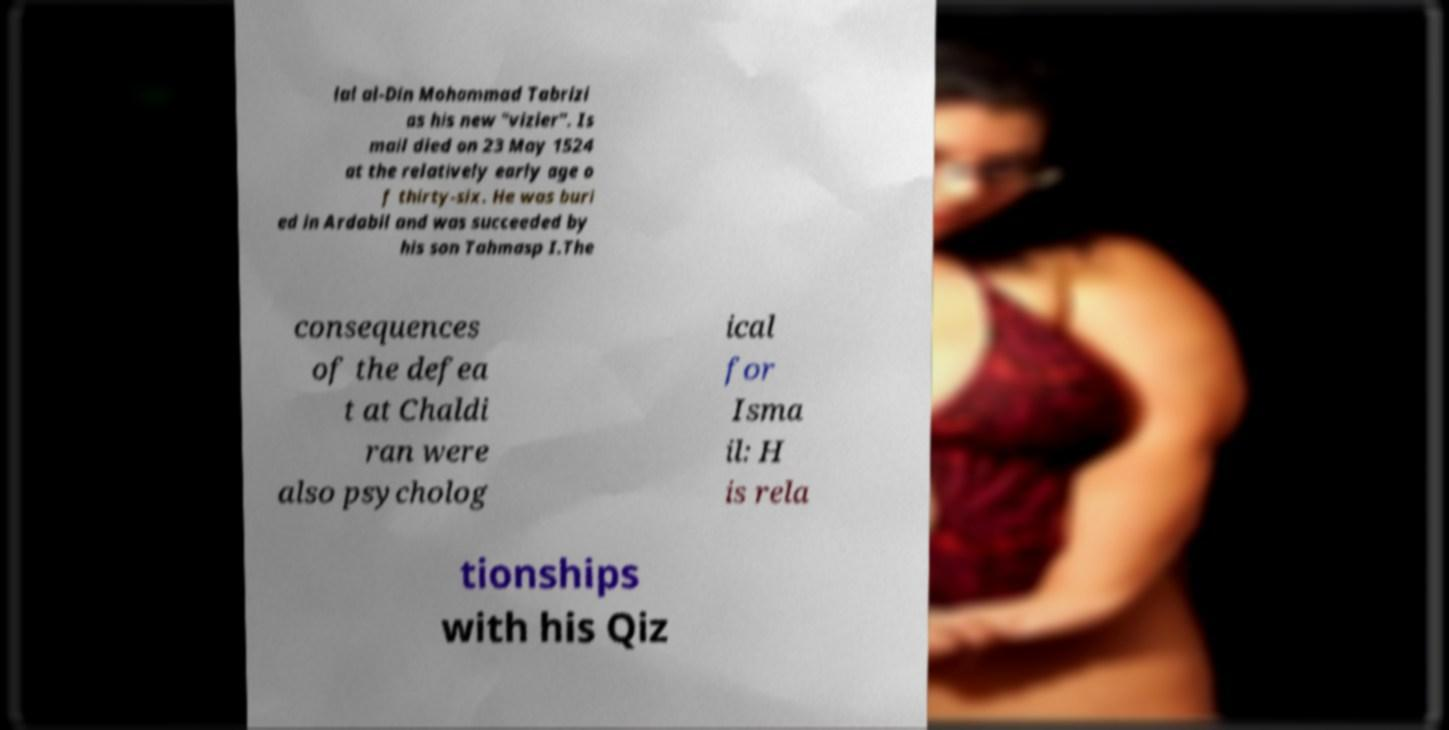What messages or text are displayed in this image? I need them in a readable, typed format. lal al-Din Mohammad Tabrizi as his new "vizier". Is mail died on 23 May 1524 at the relatively early age o f thirty-six. He was buri ed in Ardabil and was succeeded by his son Tahmasp I.The consequences of the defea t at Chaldi ran were also psycholog ical for Isma il: H is rela tionships with his Qiz 